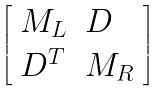<formula> <loc_0><loc_0><loc_500><loc_500>\left [ \begin{array} { l l } { { M _ { L } } } & { D } \\ { { D ^ { T } } } & { { M _ { R } } } \end{array} \right ]</formula> 